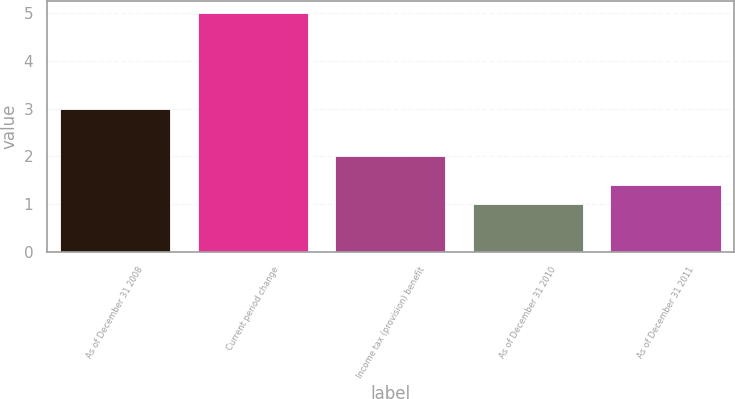Convert chart to OTSL. <chart><loc_0><loc_0><loc_500><loc_500><bar_chart><fcel>As of December 31 2008<fcel>Current period change<fcel>Income tax (provision) benefit<fcel>As of December 31 2010<fcel>As of December 31 2011<nl><fcel>3<fcel>5<fcel>2<fcel>1<fcel>1.4<nl></chart> 